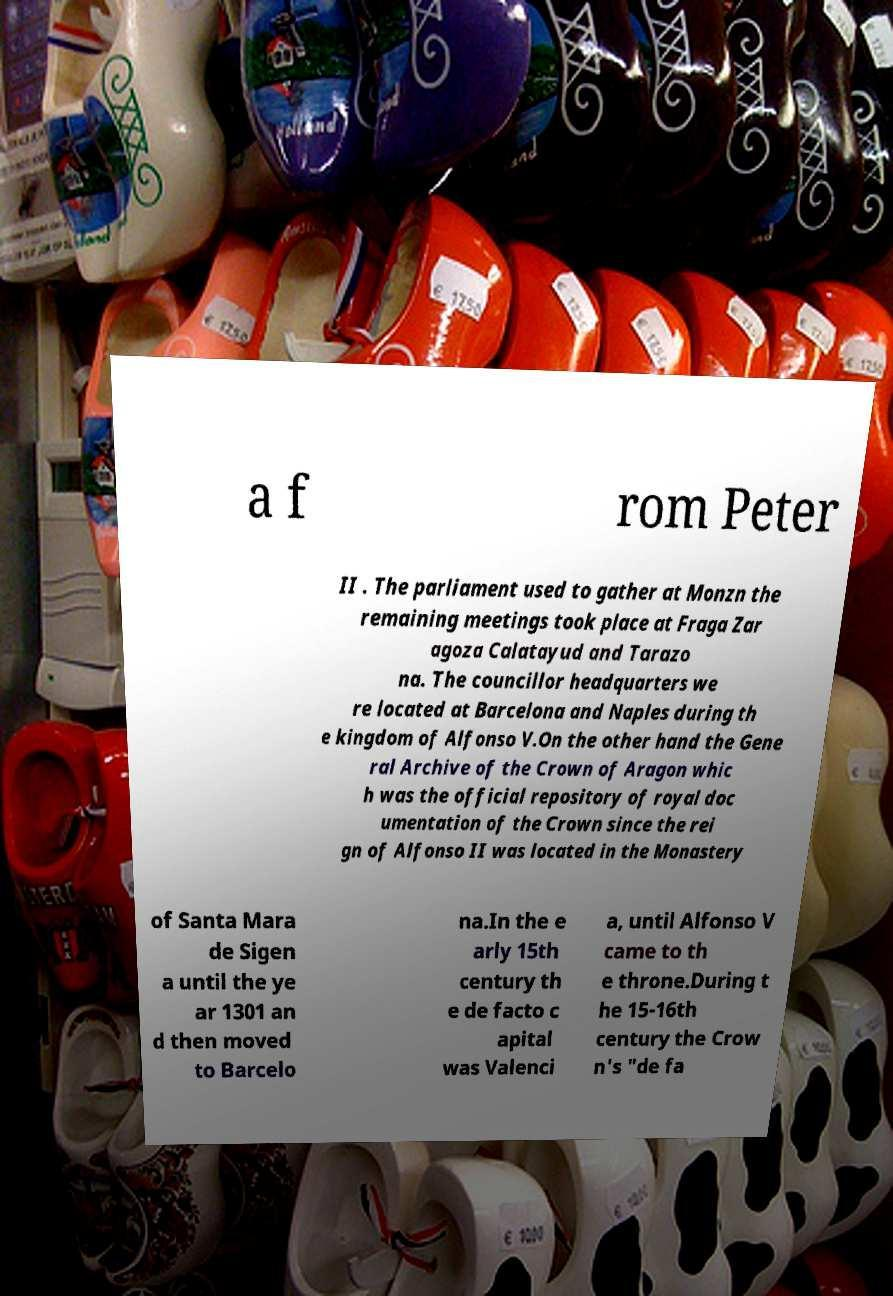Can you read and provide the text displayed in the image?This photo seems to have some interesting text. Can you extract and type it out for me? a f rom Peter II . The parliament used to gather at Monzn the remaining meetings took place at Fraga Zar agoza Calatayud and Tarazo na. The councillor headquarters we re located at Barcelona and Naples during th e kingdom of Alfonso V.On the other hand the Gene ral Archive of the Crown of Aragon whic h was the official repository of royal doc umentation of the Crown since the rei gn of Alfonso II was located in the Monastery of Santa Mara de Sigen a until the ye ar 1301 an d then moved to Barcelo na.In the e arly 15th century th e de facto c apital was Valenci a, until Alfonso V came to th e throne.During t he 15-16th century the Crow n's "de fa 